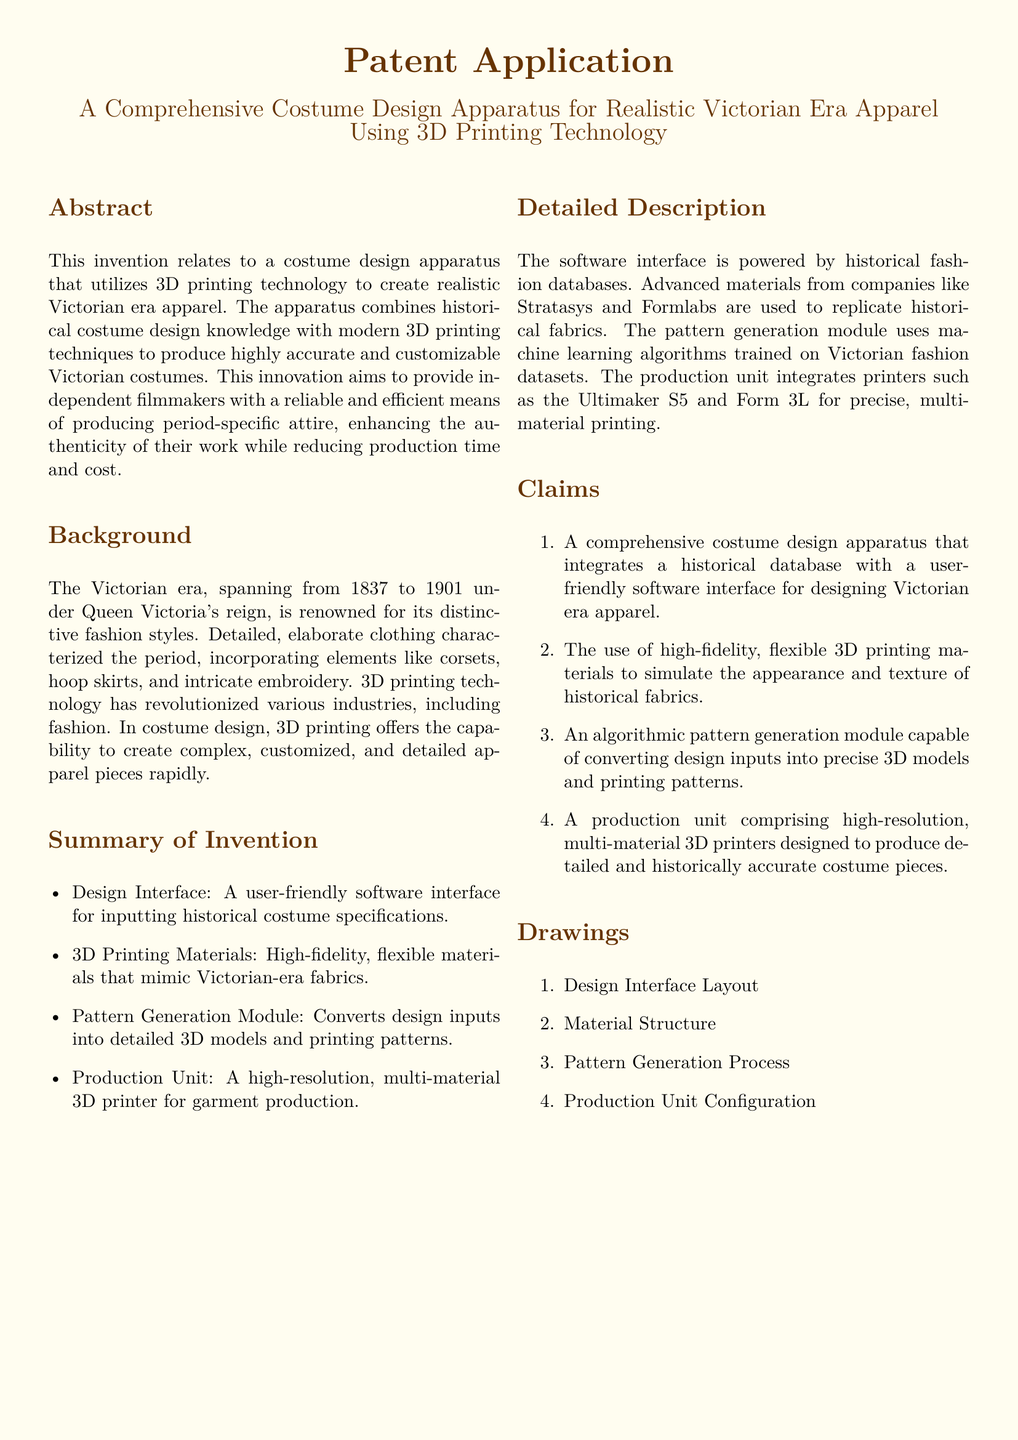What is the title of the patent application? The title of the patent application is prominently displayed at the top of the document.
Answer: A Comprehensive Costume Design Apparatus for Realistic Victorian Era Apparel Using 3D Printing Technology What time period does the Victorian era cover? The document specifies the years during which the Victorian era took place.
Answer: 1837 to 1901 What is the function of the pattern generation module? The document describes the role of the pattern generation module in the costume design process.
Answer: Converts design inputs into detailed 3D models and printing patterns Which printing technology is primarily used in this apparatus? The document emphasizes the use of a specific technology for producing costumes.
Answer: 3D printing technology Who is the target audience for this invention? The document mentions the intended users who would benefit from the invention.
Answer: Independent filmmakers What type of materials does the invention utilize? The document details the characteristics of the materials used in the production process.
Answer: High-fidelity, flexible materials What is claimed as the first feature of the invention? The document lists the features claimed in the patent application, starting with the first one.
Answer: A comprehensive costume design apparatus How many drawings are included in the patent application? The document lists the drawings that accompany the application.
Answer: Four 